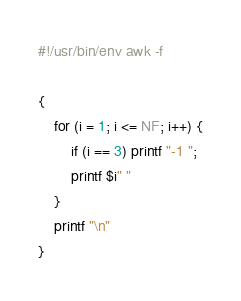Convert code to text. <code><loc_0><loc_0><loc_500><loc_500><_Awk_>#!/usr/bin/env awk -f

{
    for (i = 1; i <= NF; i++) {
        if (i == 3) printf "-1 ";
        printf $i" "
    }
    printf "\n"
}</code> 